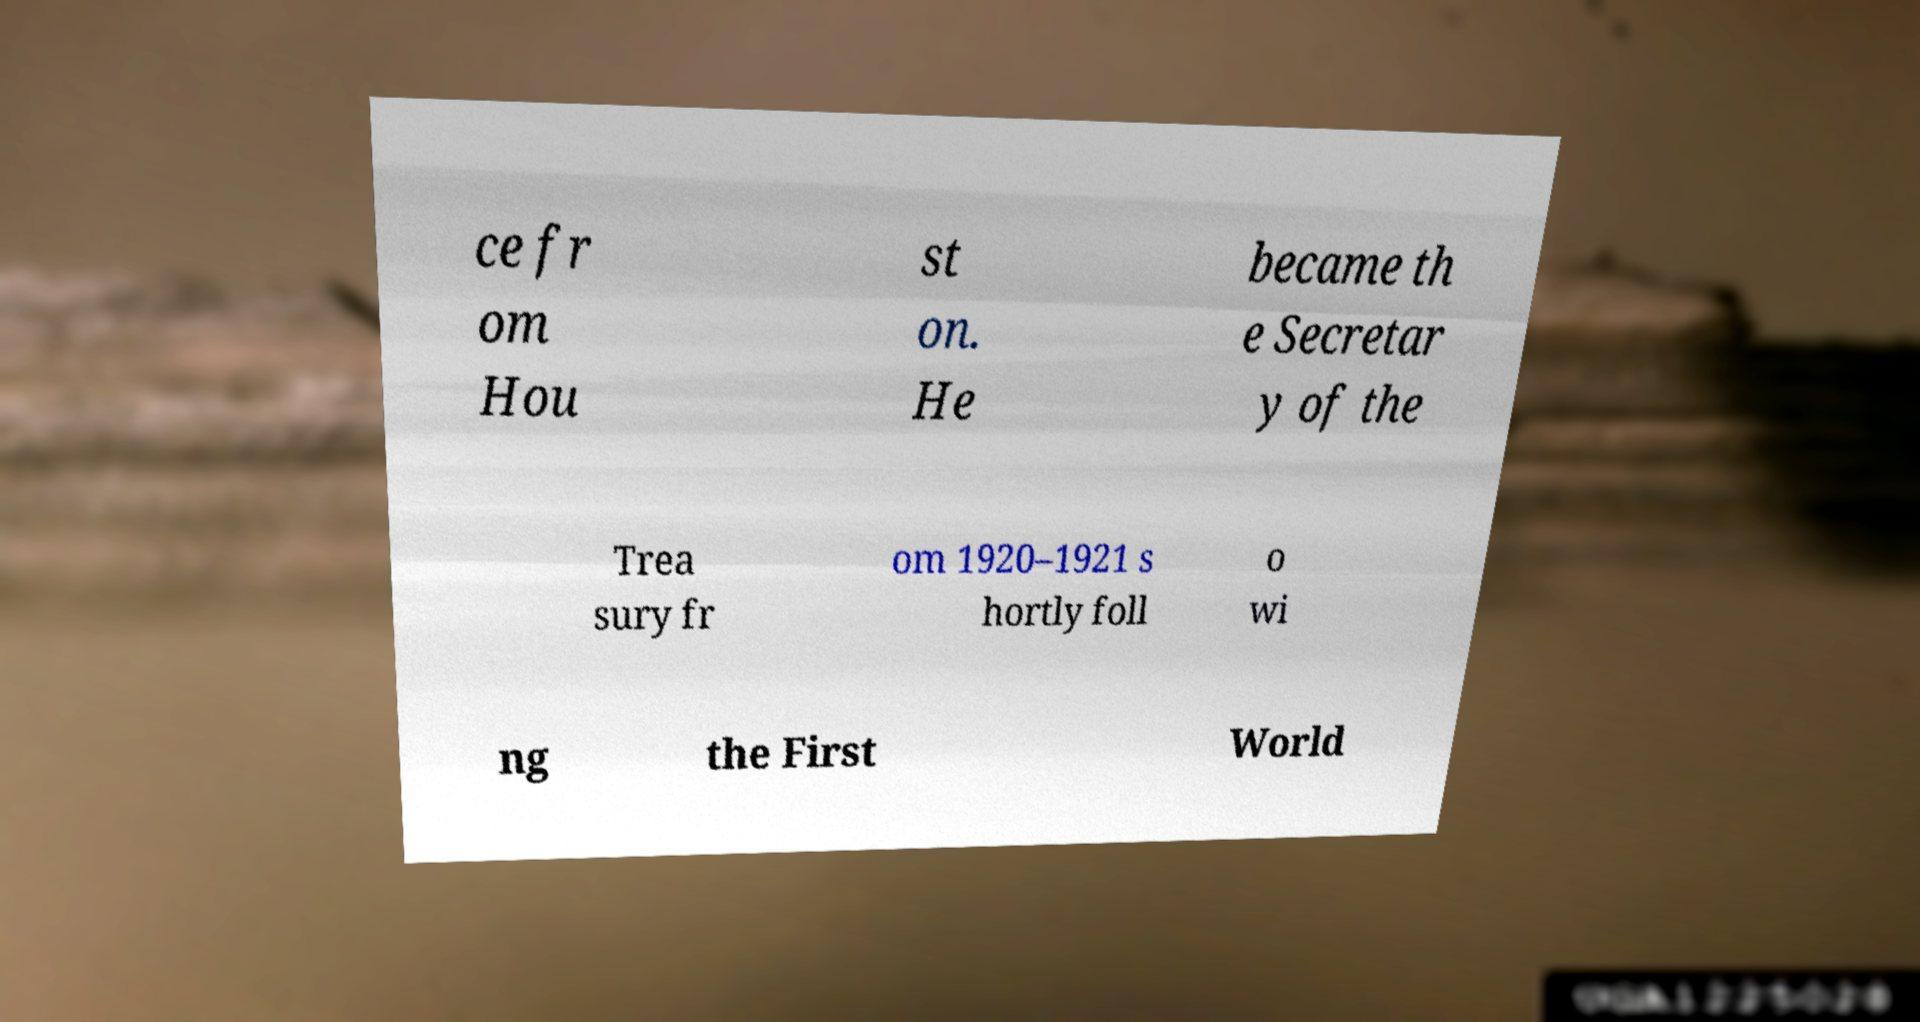Could you extract and type out the text from this image? ce fr om Hou st on. He became th e Secretar y of the Trea sury fr om 1920–1921 s hortly foll o wi ng the First World 